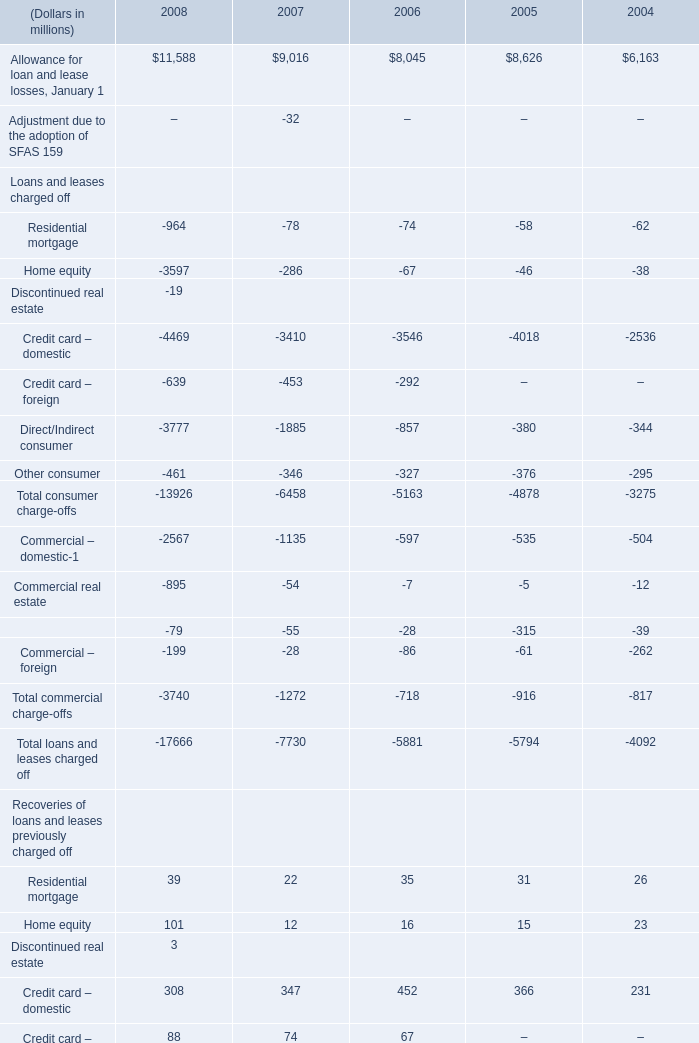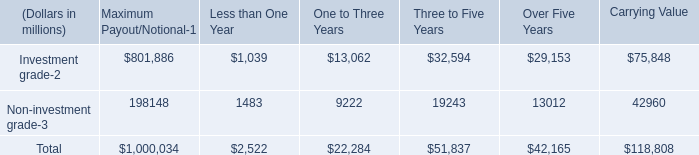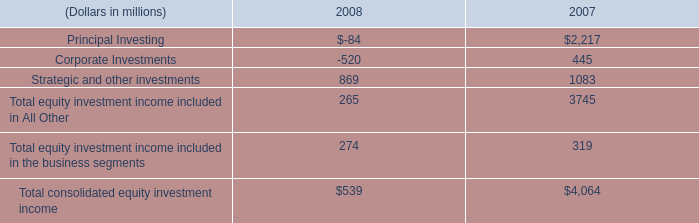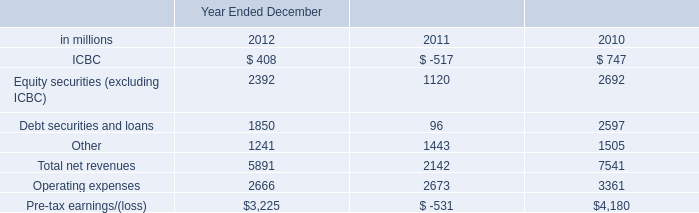What will Allowance for loan and lease losses, January 1 be like in 2009 if it develops with the same increasing rate as current? (in millions) 
Computations: ((1 + ((11588 - 9016) / 9016)) * 11588)
Answer: 14893.71606. 